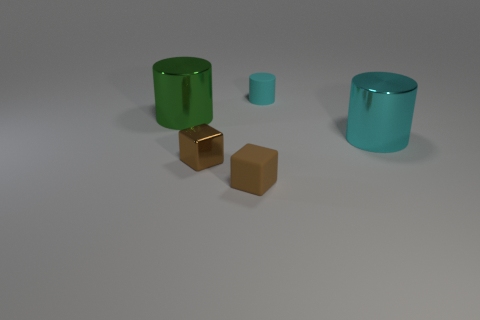What can you infer about the sizes of the objects relative to each other? The cylindrical objects exhibit a size gradient, with one being larger and the other smaller. The two cubes are relatively smaller in size compared to the cylinders, and they are similar in size to each other, indicating a deliberate scaling and placement. 